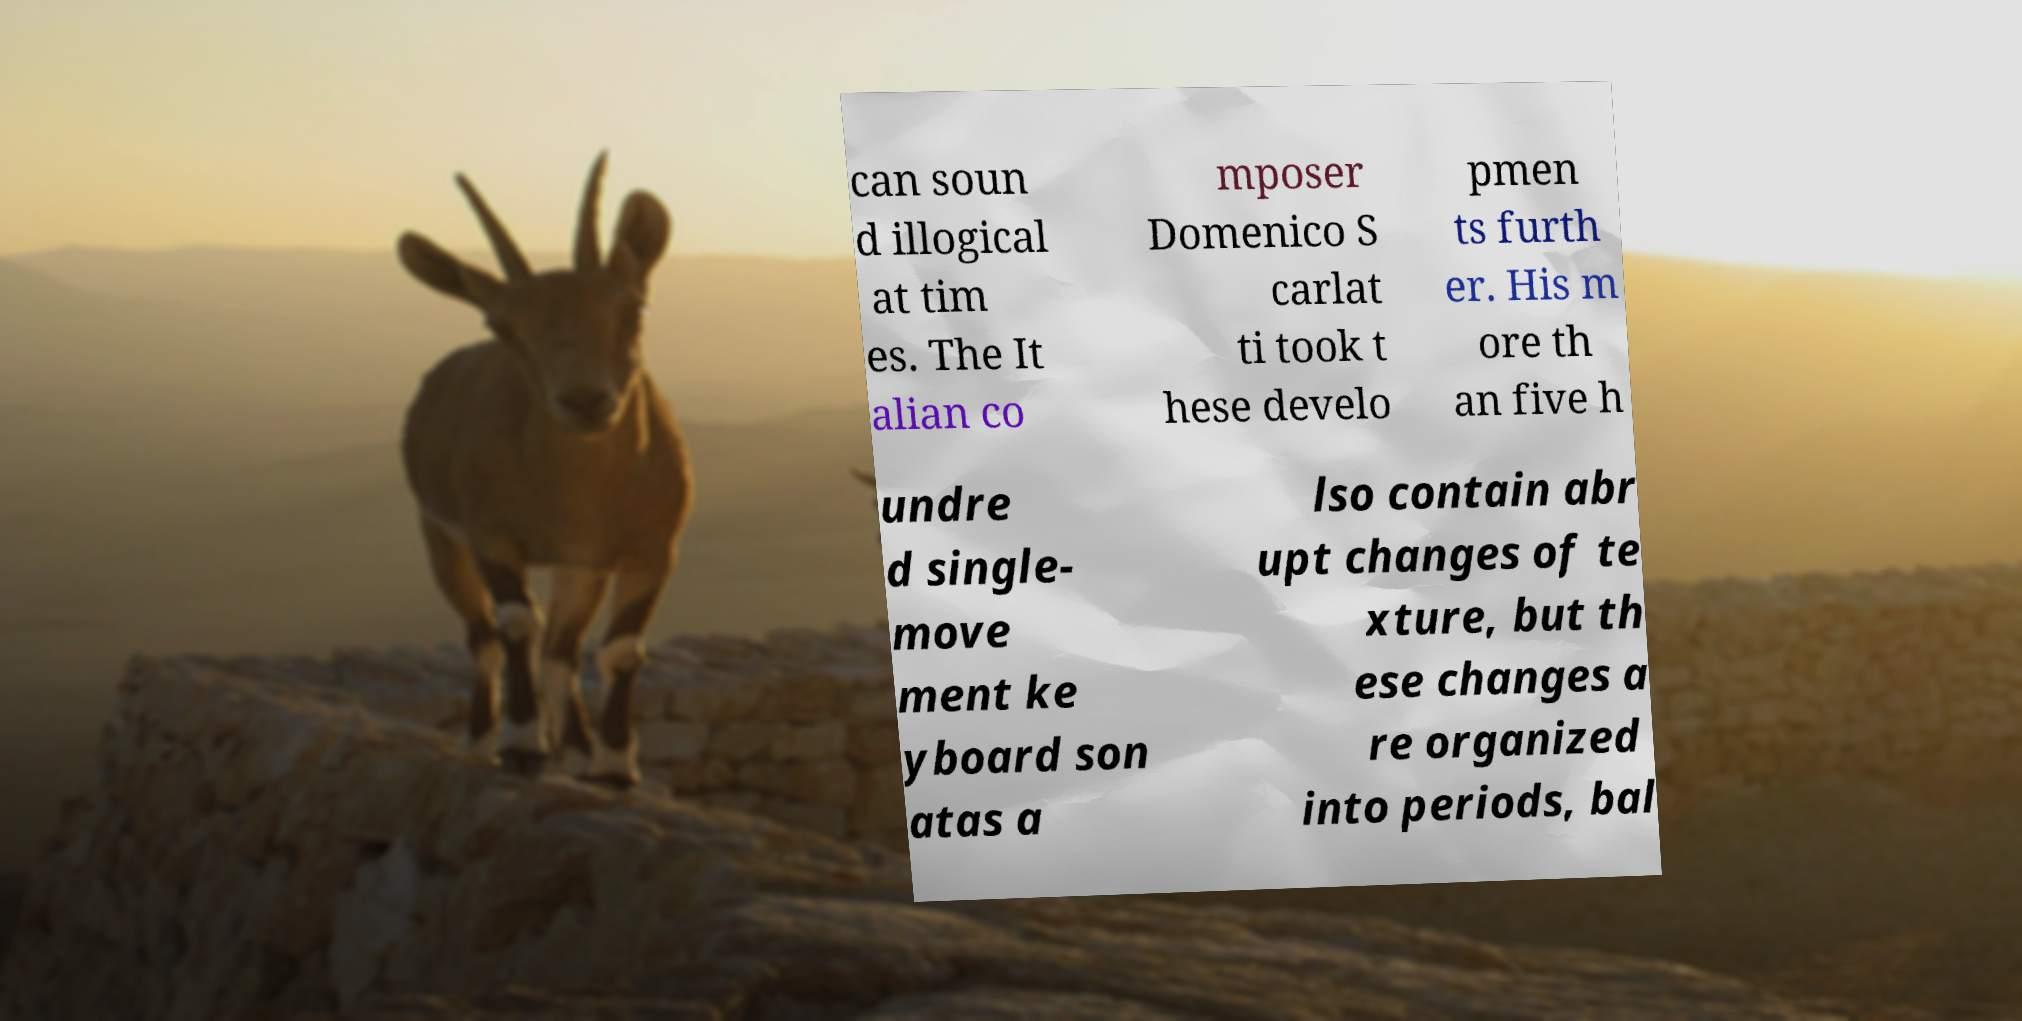Could you assist in decoding the text presented in this image and type it out clearly? can soun d illogical at tim es. The It alian co mposer Domenico S carlat ti took t hese develo pmen ts furth er. His m ore th an five h undre d single- move ment ke yboard son atas a lso contain abr upt changes of te xture, but th ese changes a re organized into periods, bal 